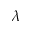Convert formula to latex. <formula><loc_0><loc_0><loc_500><loc_500>\lambda</formula> 